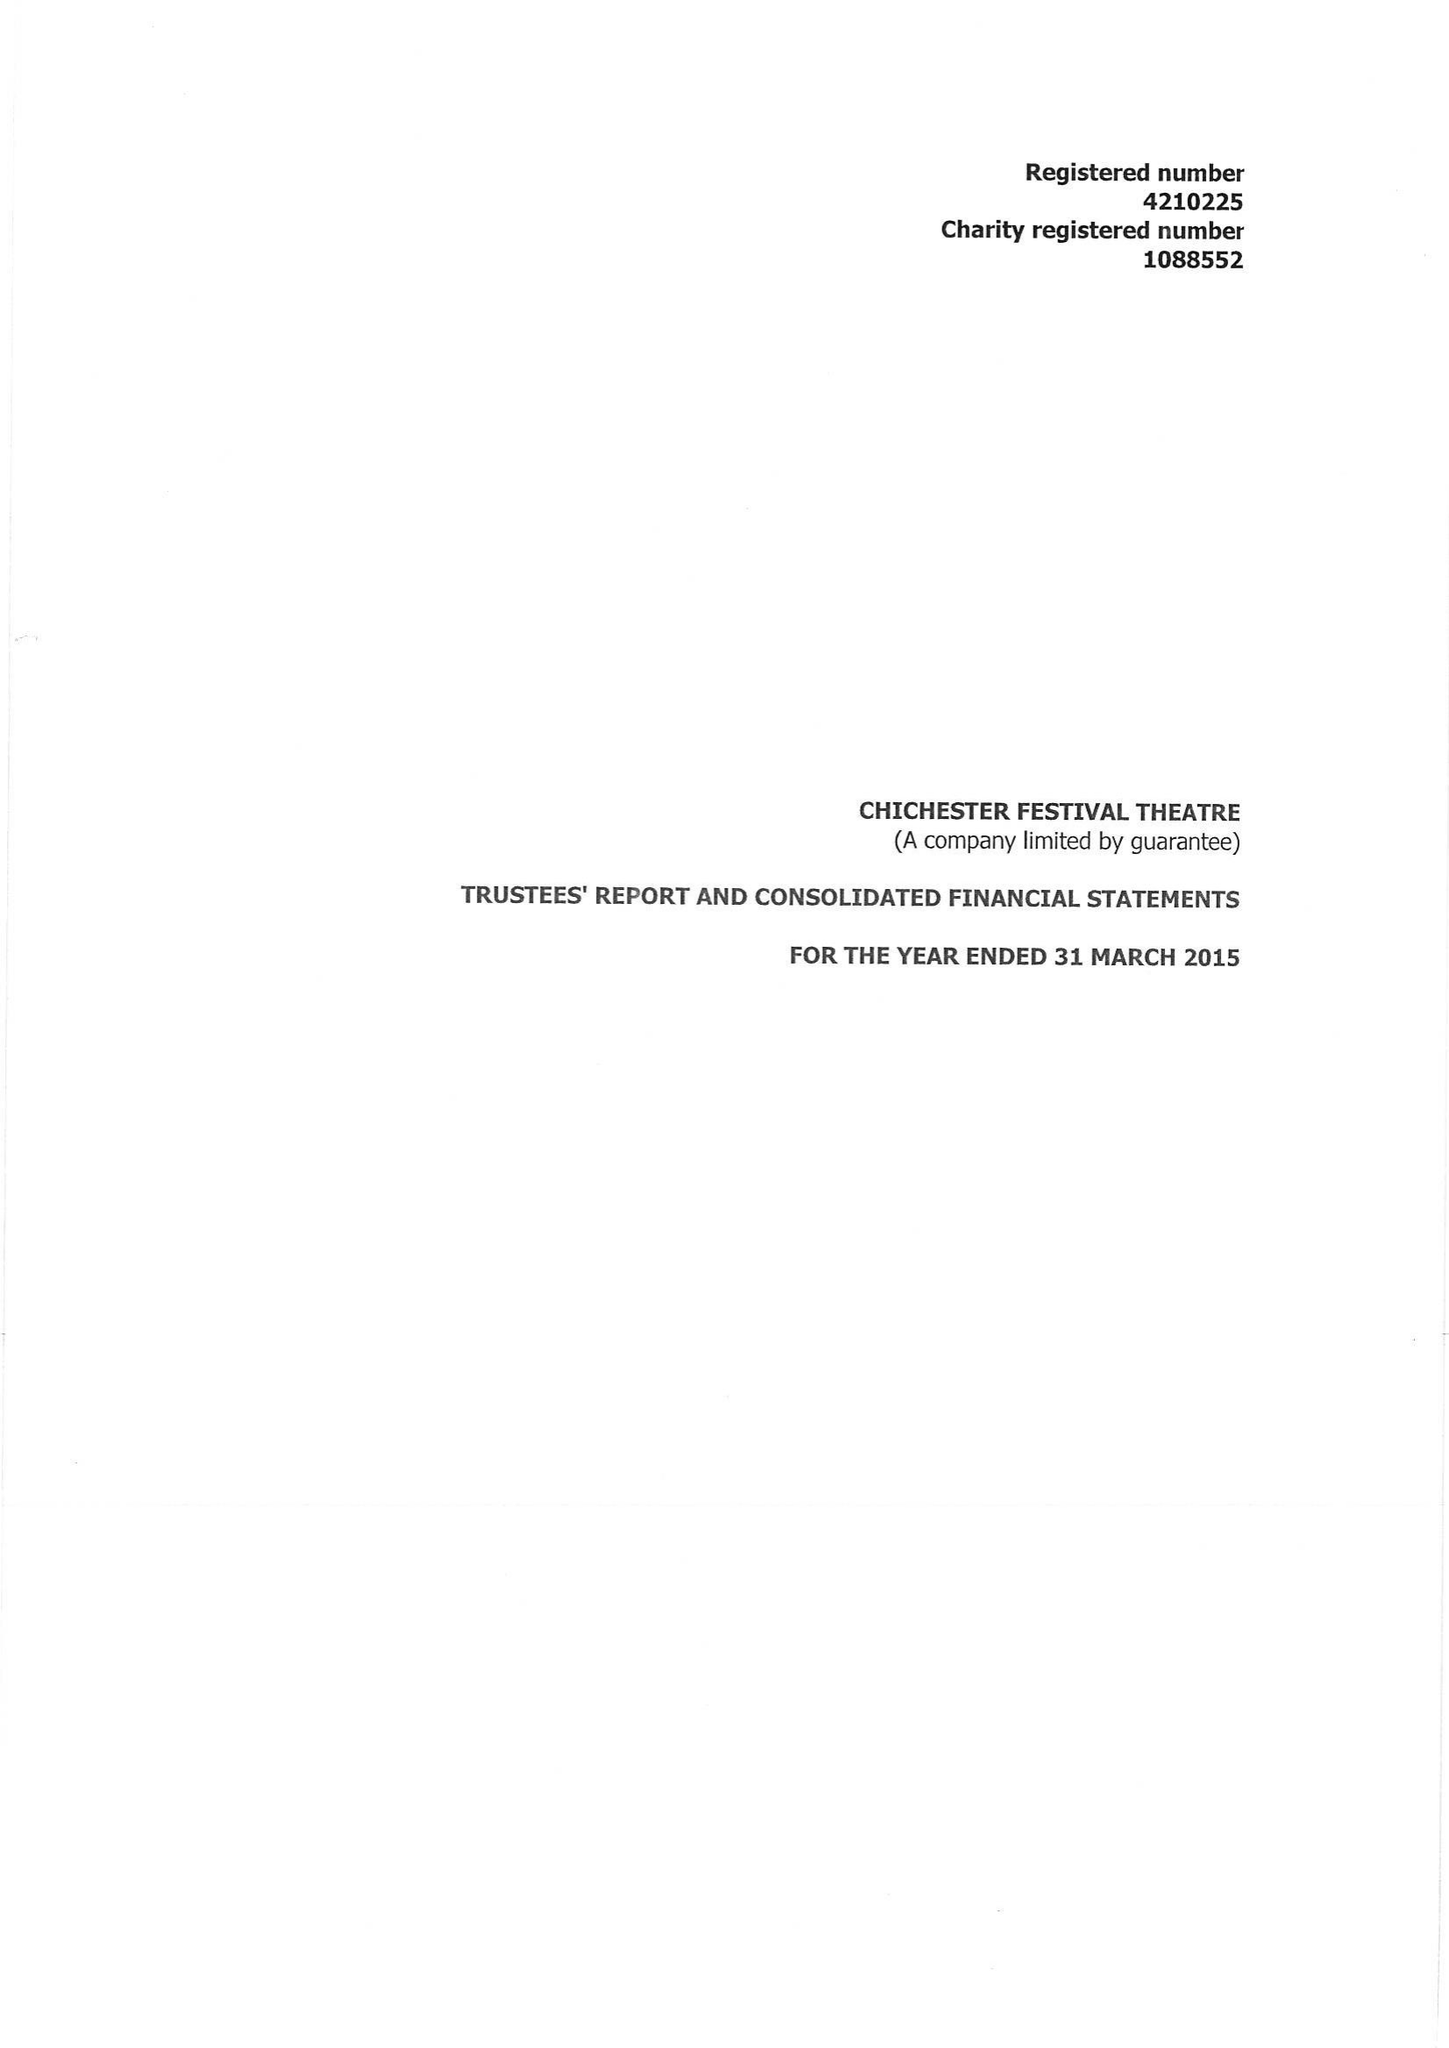What is the value for the charity_name?
Answer the question using a single word or phrase. Chichester Festival Theatre 